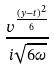<formula> <loc_0><loc_0><loc_500><loc_500>\frac { v ^ { \frac { ( y - t ) ^ { 2 } } { 6 } } } { i \sqrt { 6 \omega } }</formula> 